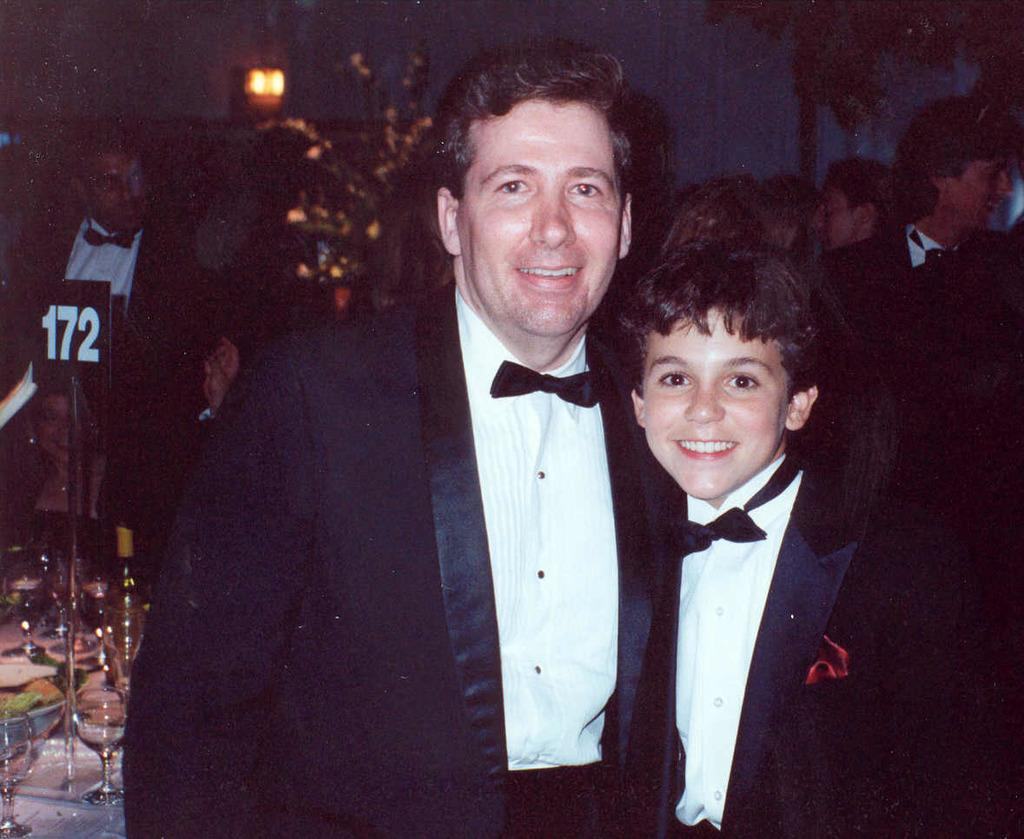Who is present in the image? There is a man and a boy in the image. What are the man and the boy wearing? Both the man and the boy are wearing blazers and bow ties. What expression do the man and the boy have? Both the man and the boy are smiling. What can be seen in the background of the image? There are people, glasses, a bottle, a light, and trees in the background of the image. What joke is the man telling the boy in the image? There is no indication in the image that the man is telling a joke to the boy. What is the purpose of the light in the background of the image? The purpose of the light in the background of the image cannot be determined from the image alone. --- Facts: 1. There is a car in the image. 2. The car is red. 3. The car has four wheels. 4. The car has a license plate. 5. The license plate has numbers and letters. 6. The car is parked on the street. 7. There are trees on the street. 8. There are buildings on the street. Absurd Topics: bird, ocean, mountain Conversation: What is the main subject of the image? The main subject of the image is a car. What color is the car? The car is red. How many wheels does the car have? The car has four wheels. What can be seen on the car? The car has a license plate. What is written on the license plate? The license plate has numbers and letters. Where is the car parked? The car is parked on the street. What can be seen on the street? There are trees and buildings on the street. Reasoning: Let's think step by step in order to produce the conversation. We start by identifying the main subject of the image, which is the car. Then, we describe specific features of the car, such as its color, the number of wheels it has, and the presence of a license plate. Next, we observe the actions of the car, noting that it is parked on the street. Finally, we describe the natural setting visible on the street, mentioning the presence of trees and buildings. Absurd Question/Answer: What type of bird can be seen sitting on the car in the image? There is no bird present in the image. 